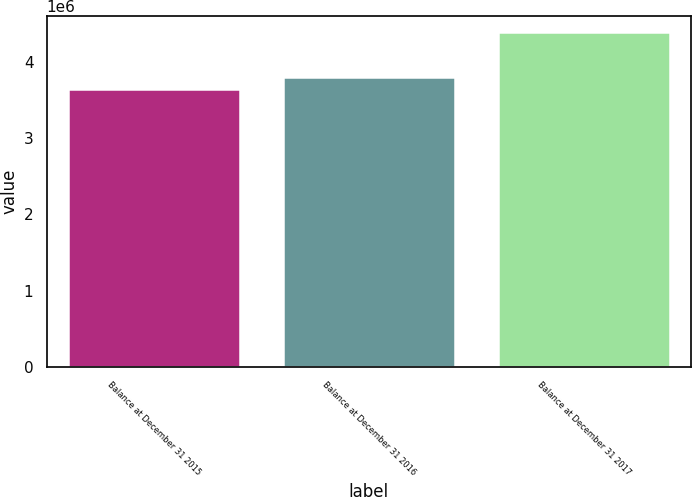Convert chart. <chart><loc_0><loc_0><loc_500><loc_500><bar_chart><fcel>Balance at December 31 2015<fcel>Balance at December 31 2016<fcel>Balance at December 31 2017<nl><fcel>3.64458e+06<fcel>3.79975e+06<fcel>4.38318e+06<nl></chart> 